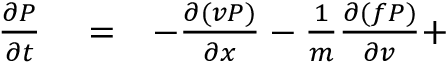<formula> <loc_0><loc_0><loc_500><loc_500>\begin{array} { r l r } { { \frac { \partial P } { \partial t } } } & = } & { - { \frac { \partial ( v P ) } { \partial x } } - { \frac { 1 } { m } } { \frac { \partial ( f P ) } { \partial v } } + } \end{array}</formula> 